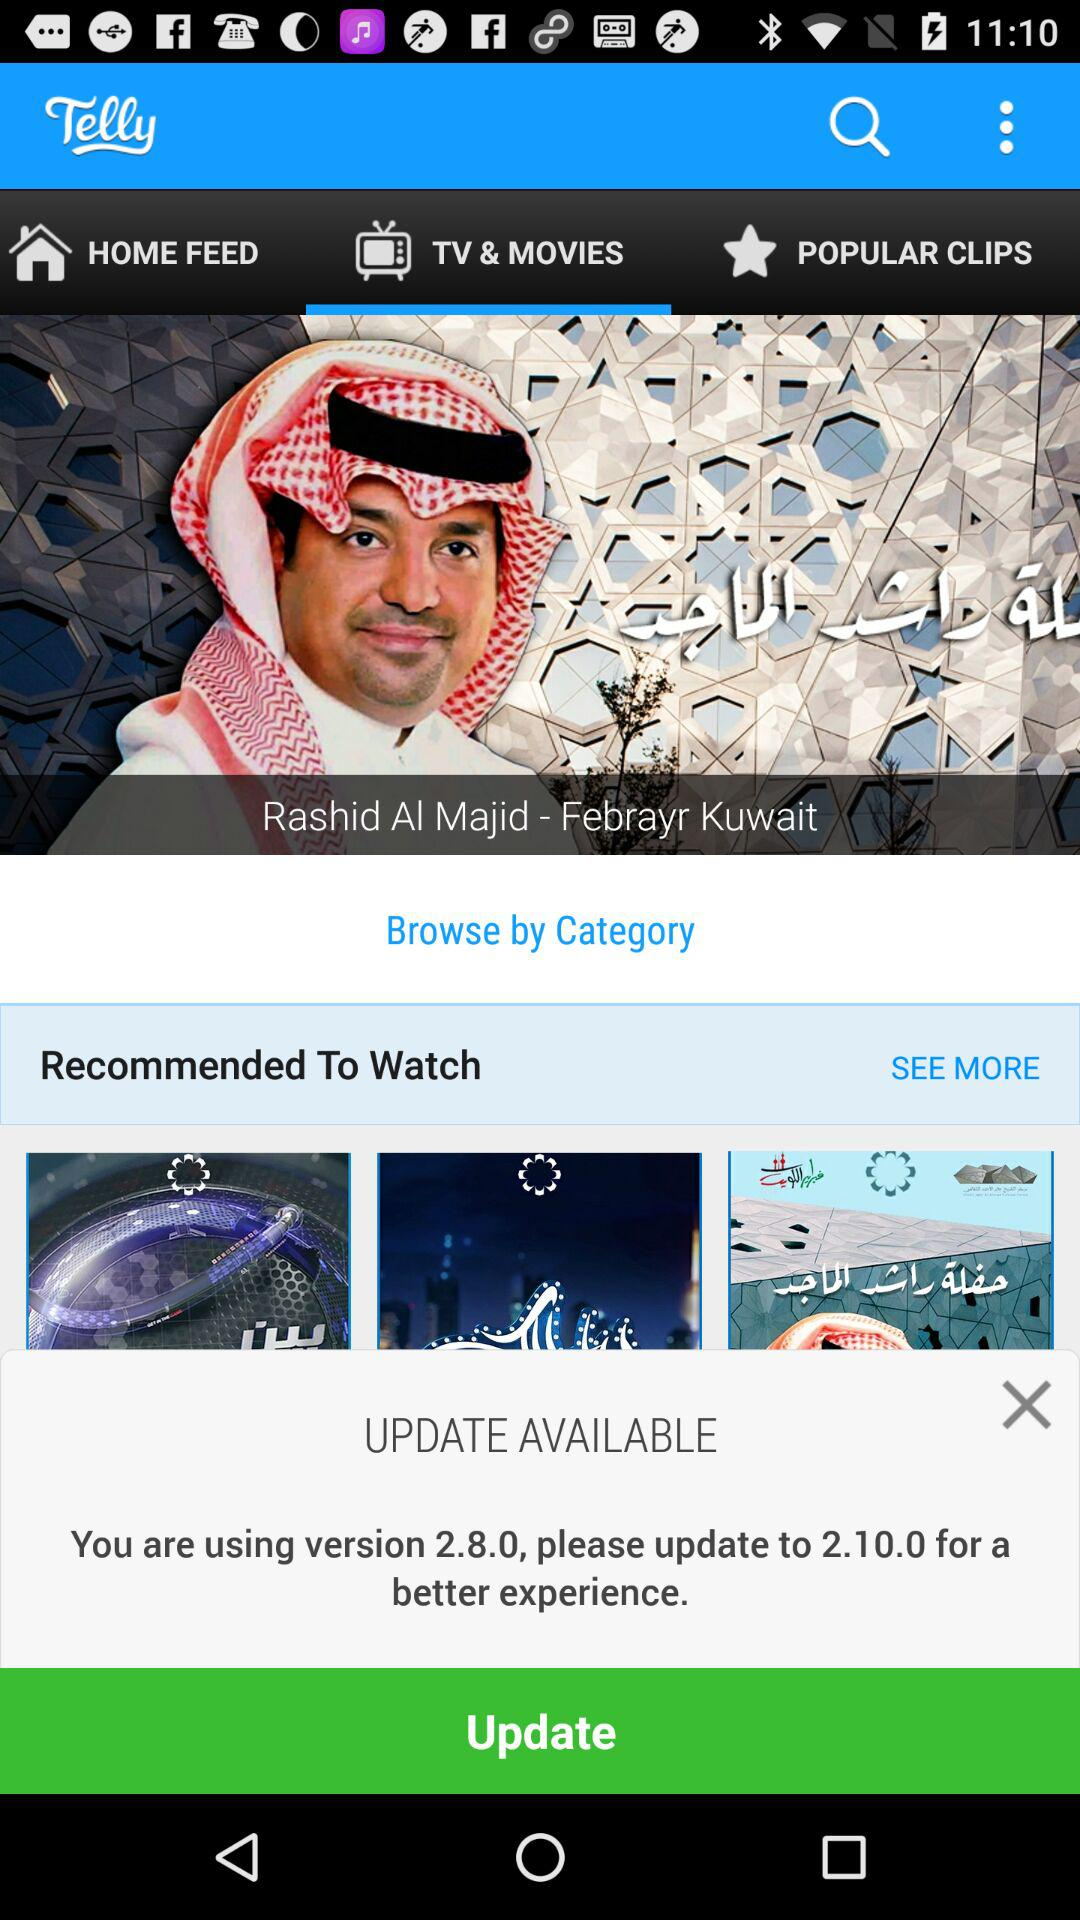What is the application name? The application name is "Telly". 